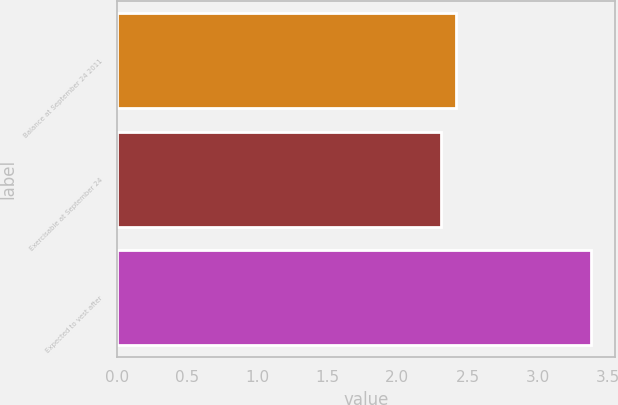<chart> <loc_0><loc_0><loc_500><loc_500><bar_chart><fcel>Balance at September 24 2011<fcel>Exercisable at September 24<fcel>Expected to vest after<nl><fcel>2.42<fcel>2.31<fcel>3.38<nl></chart> 